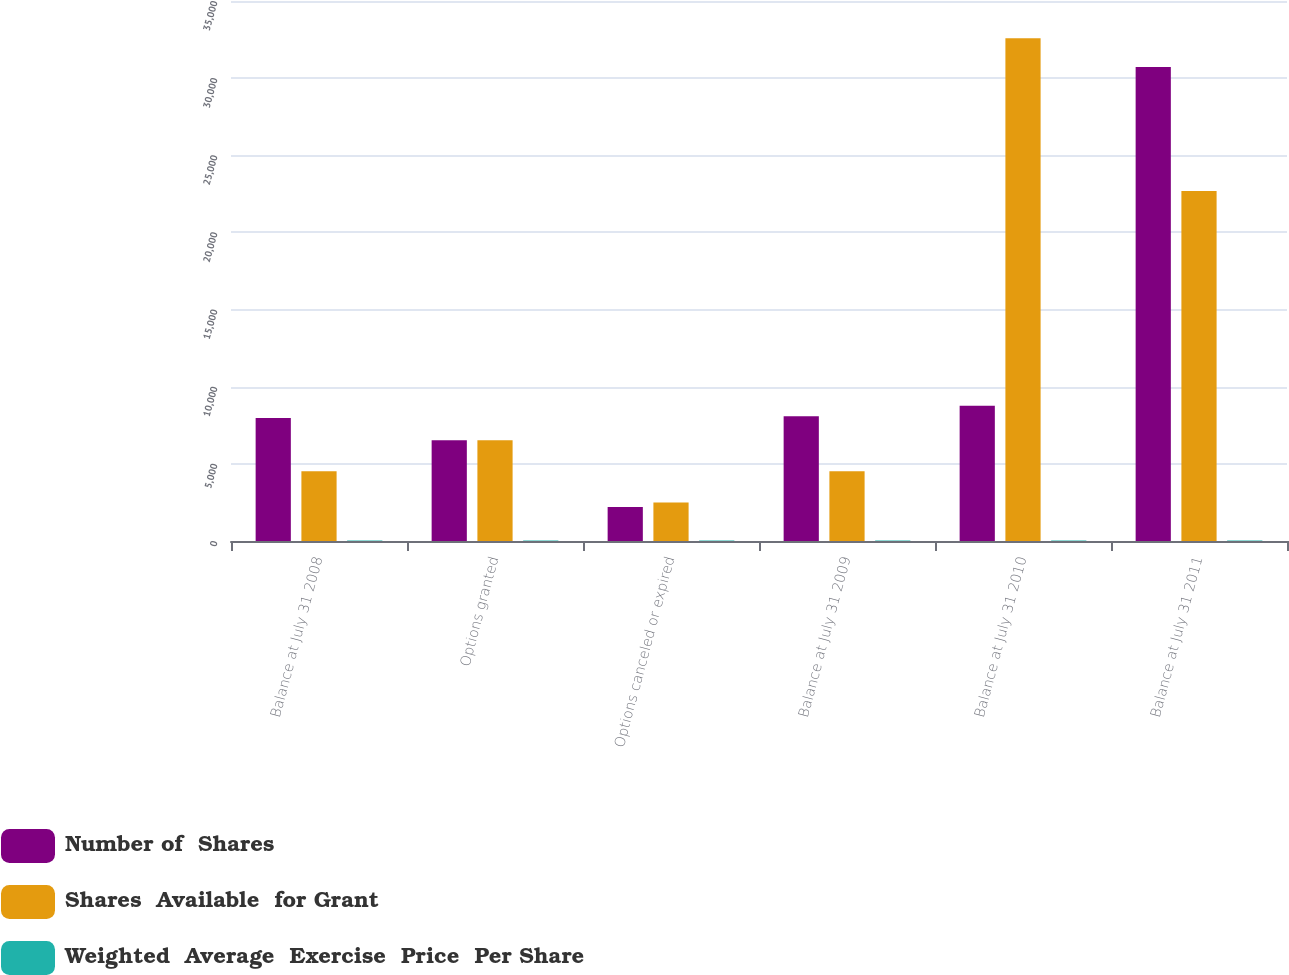<chart> <loc_0><loc_0><loc_500><loc_500><stacked_bar_chart><ecel><fcel>Balance at July 31 2008<fcel>Options granted<fcel>Options canceled or expired<fcel>Balance at July 31 2009<fcel>Balance at July 31 2010<fcel>Balance at July 31 2011<nl><fcel>Number of  Shares<fcel>7976<fcel>6538<fcel>2208<fcel>8086<fcel>8761<fcel>30716<nl><fcel>Shares  Available  for Grant<fcel>4513<fcel>6538<fcel>2488<fcel>4513<fcel>32593<fcel>22679<nl><fcel>Weighted  Average  Exercise  Price  Per Share<fcel>24.7<fcel>28.83<fcel>29.2<fcel>26<fcel>28.45<fcel>32.38<nl></chart> 